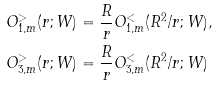<formula> <loc_0><loc_0><loc_500><loc_500>O _ { 1 , m } ^ { > } ( r ; W ) & = \frac { R } { r } O _ { 1 , m } ^ { < } ( R ^ { 2 } / r ; W ) , \\ O _ { 3 , m } ^ { > } ( r ; W ) & = \frac { R } { r } O _ { 3 , m } ^ { < } ( R ^ { 2 } / r ; W )</formula> 